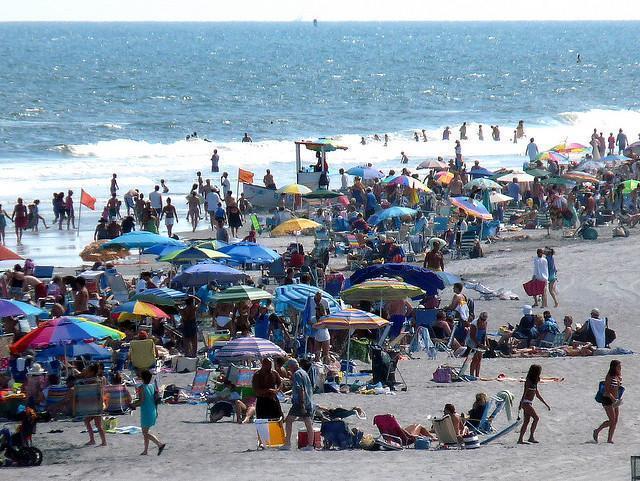What is the person in the elevated stand watching?
Select the accurate response from the four choices given to answer the question.
Options: Sunset, swimmers, boats, sea slugs. Swimmers. 